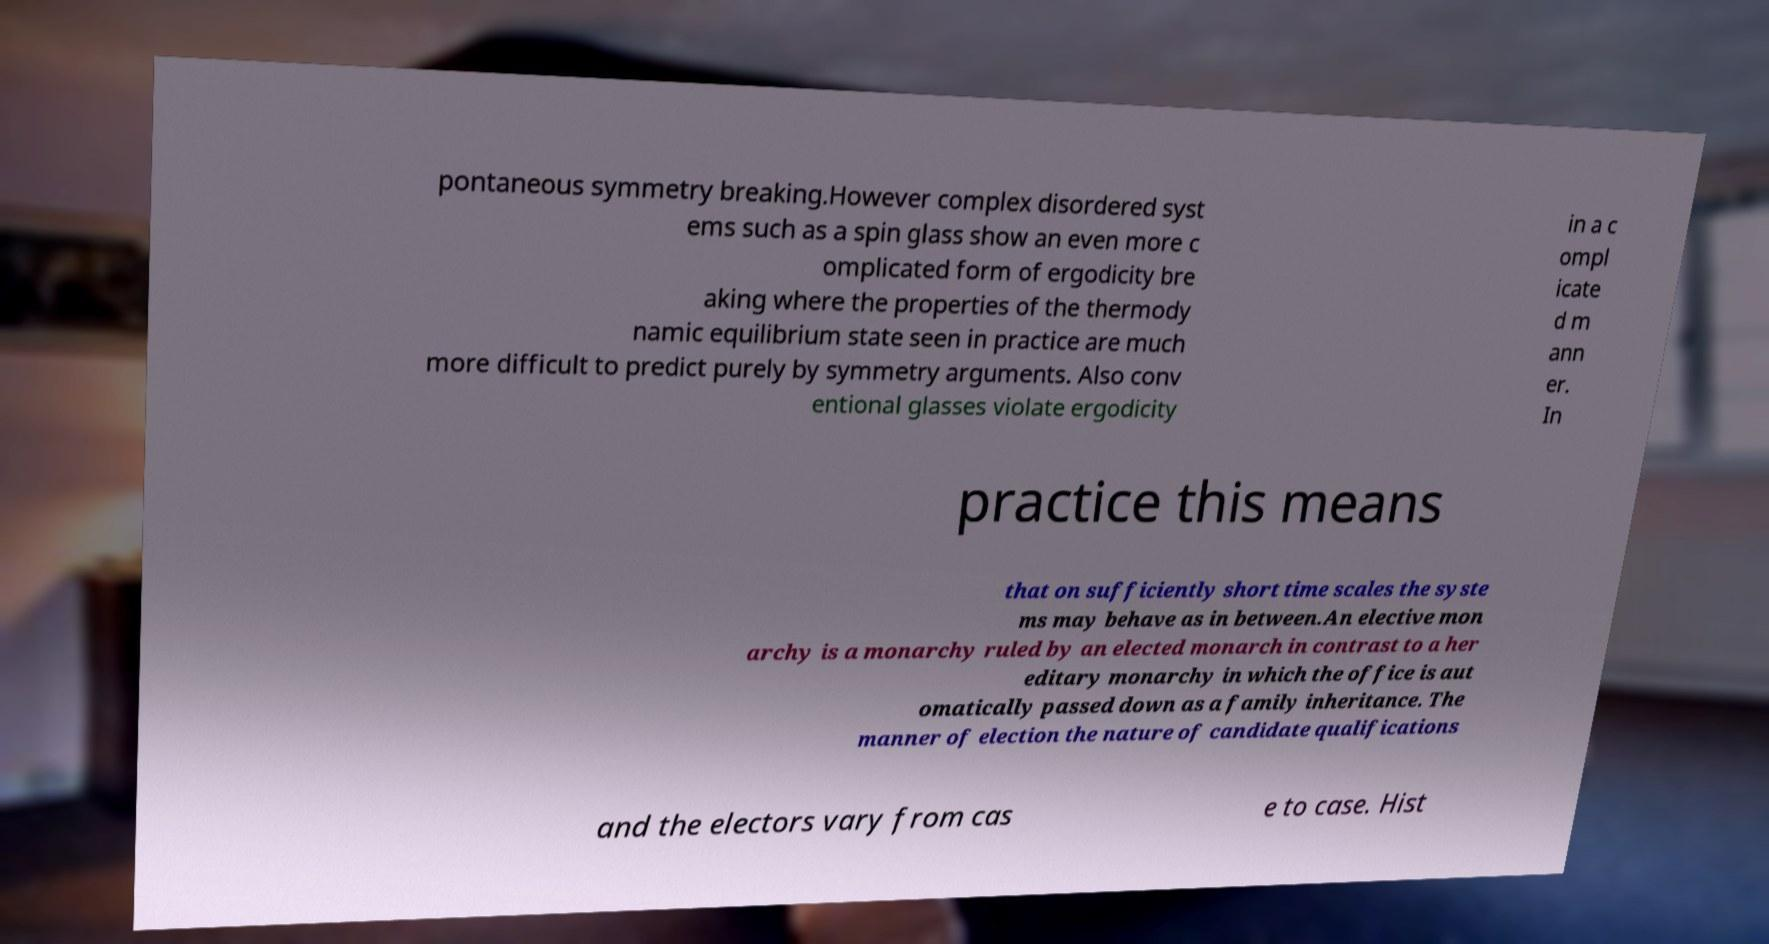Please read and relay the text visible in this image. What does it say? pontaneous symmetry breaking.However complex disordered syst ems such as a spin glass show an even more c omplicated form of ergodicity bre aking where the properties of the thermody namic equilibrium state seen in practice are much more difficult to predict purely by symmetry arguments. Also conv entional glasses violate ergodicity in a c ompl icate d m ann er. In practice this means that on sufficiently short time scales the syste ms may behave as in between.An elective mon archy is a monarchy ruled by an elected monarch in contrast to a her editary monarchy in which the office is aut omatically passed down as a family inheritance. The manner of election the nature of candidate qualifications and the electors vary from cas e to case. Hist 